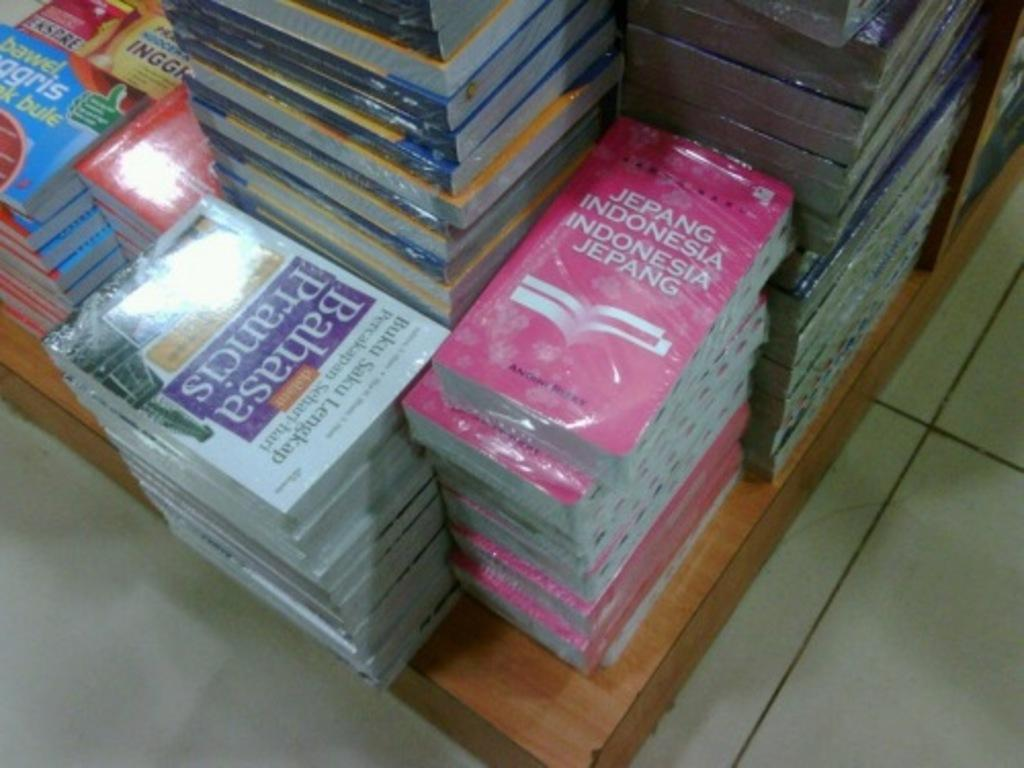<image>
Present a compact description of the photo's key features. Bahasa Prauncis stack of books and a stack of Jepang Indonesia books. 